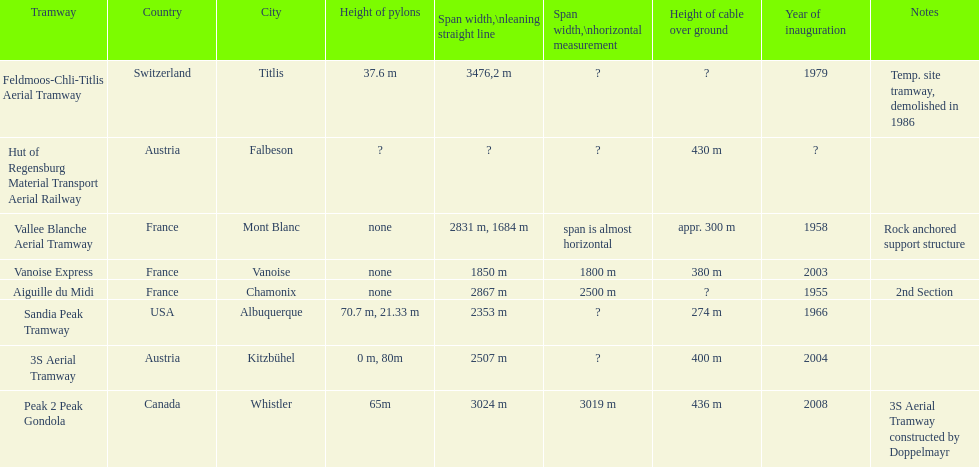Was the peak 2 peak gondola inaugurated before the vanoise express? No. 